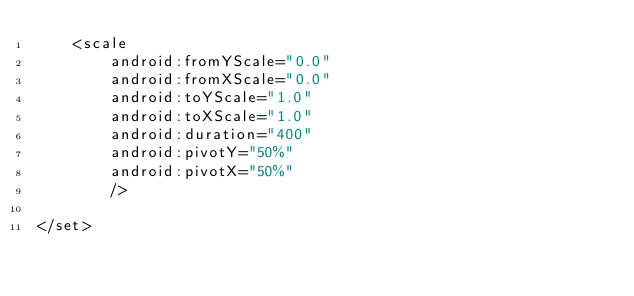<code> <loc_0><loc_0><loc_500><loc_500><_XML_>    <scale
        android:fromYScale="0.0"
        android:fromXScale="0.0"
        android:toYScale="1.0"
        android:toXScale="1.0"
        android:duration="400"
        android:pivotY="50%"
        android:pivotX="50%"
        />

</set></code> 